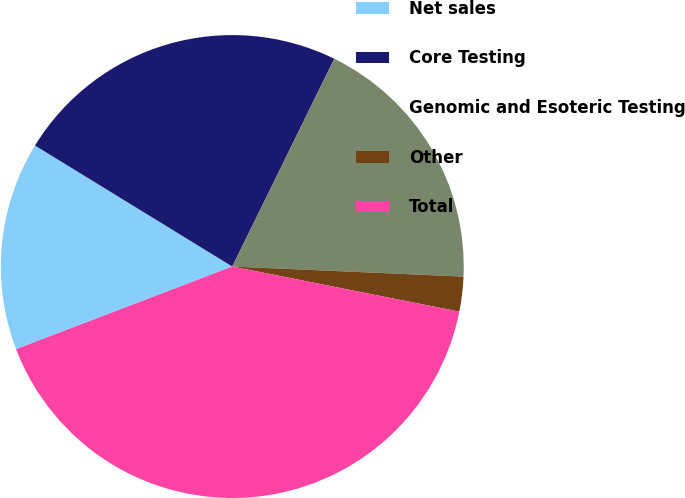<chart> <loc_0><loc_0><loc_500><loc_500><pie_chart><fcel>Net sales<fcel>Core Testing<fcel>Genomic and Esoteric Testing<fcel>Other<fcel>Total<nl><fcel>14.57%<fcel>23.51%<fcel>18.43%<fcel>2.43%<fcel>41.07%<nl></chart> 